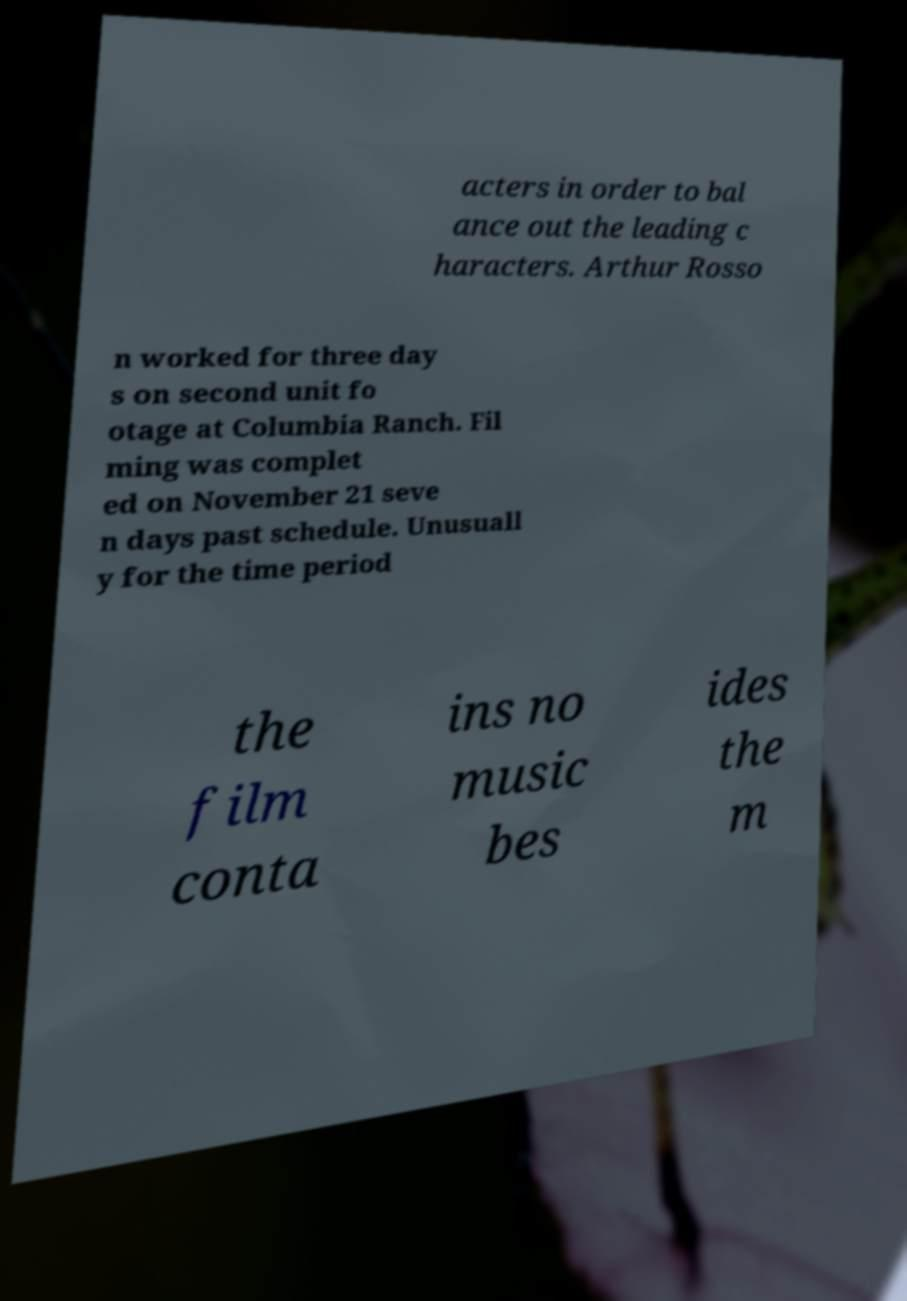There's text embedded in this image that I need extracted. Can you transcribe it verbatim? acters in order to bal ance out the leading c haracters. Arthur Rosso n worked for three day s on second unit fo otage at Columbia Ranch. Fil ming was complet ed on November 21 seve n days past schedule. Unusuall y for the time period the film conta ins no music bes ides the m 